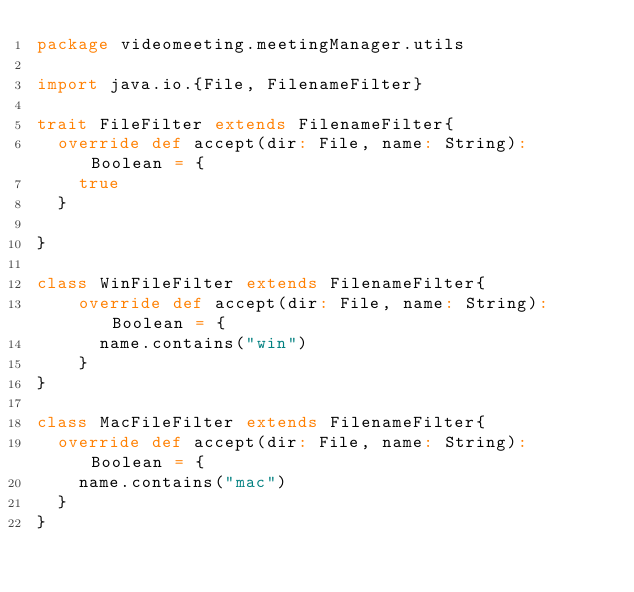<code> <loc_0><loc_0><loc_500><loc_500><_Scala_>package videomeeting.meetingManager.utils

import java.io.{File, FilenameFilter}

trait FileFilter extends FilenameFilter{
  override def accept(dir: File, name: String): Boolean = {
    true
  }

}

class WinFileFilter extends FilenameFilter{
    override def accept(dir: File, name: String): Boolean = {
      name.contains("win")
    }
}

class MacFileFilter extends FilenameFilter{
  override def accept(dir: File, name: String): Boolean = {
    name.contains("mac")
  }
}



</code> 